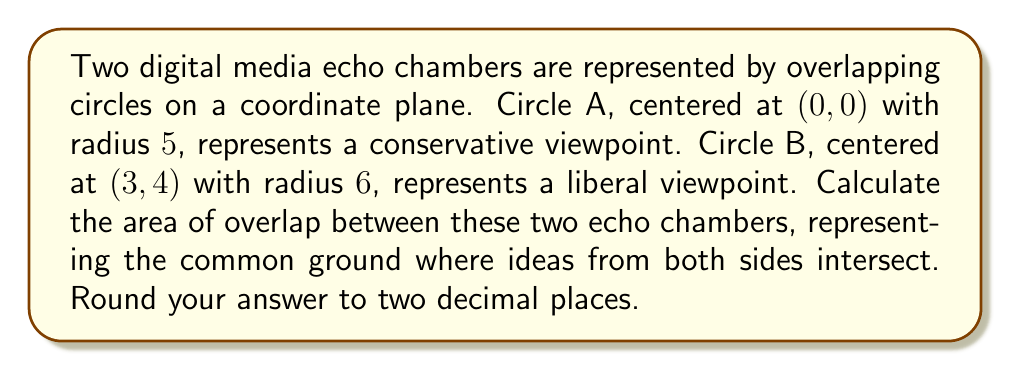Provide a solution to this math problem. Let's approach this step-by-step:

1) First, we need to find the distance between the centers of the two circles:
   $$d = \sqrt{(x_2-x_1)^2 + (y_2-y_1)^2} = \sqrt{(3-0)^2 + (4-0)^2} = 5$$

2) We have:
   Radius of Circle A: $r_1 = 5$
   Radius of Circle B: $r_2 = 6$
   Distance between centers: $d = 5$

3) To find the area of overlap, we'll use the formula:
   $$A = r_1^2 \arccos(\frac{d^2+r_1^2-r_2^2}{2dr_1}) + r_2^2 \arccos(\frac{d^2+r_2^2-r_1^2}{2dr_2}) - \frac{1}{2}\sqrt{(-d+r_1+r_2)(d+r_1-r_2)(d-r_1+r_2)(d+r_1+r_2)}$$

4) Let's calculate each part:
   $$\arccos(\frac{5^2+5^2-6^2}{2*5*5}) = \arccos(0.34) = 1.2238$$
   $$\arccos(\frac{5^2+6^2-5^2}{2*5*6}) = \arccos(0.7) = 0.7954$$
   $$\sqrt{(-5+5+6)(5+5-6)(5-5+6)(5+5+6)} = \sqrt{6 * 4 * 6 * 16} = 24$$

5) Putting it all together:
   $$A = 5^2 * 1.2238 + 6^2 * 0.7954 - \frac{1}{2} * 24$$
   $$A = 30.595 + 28.6344 - 12 = 47.2294$$

6) Rounding to two decimal places: 47.23

[asy]
import geometry;

draw(circle((0,0),5));
draw(circle((3,4),6));
draw((0,0)--(3,4),dashed);
label("A",(0,0),W);
label("B",(3,4),E);
label("5",(1.5,2),NW);
[/asy]
Answer: 47.23 square units 